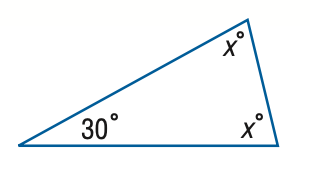Question: Find x.
Choices:
A. 60
B. 65
C. 70
D. 75
Answer with the letter. Answer: D 